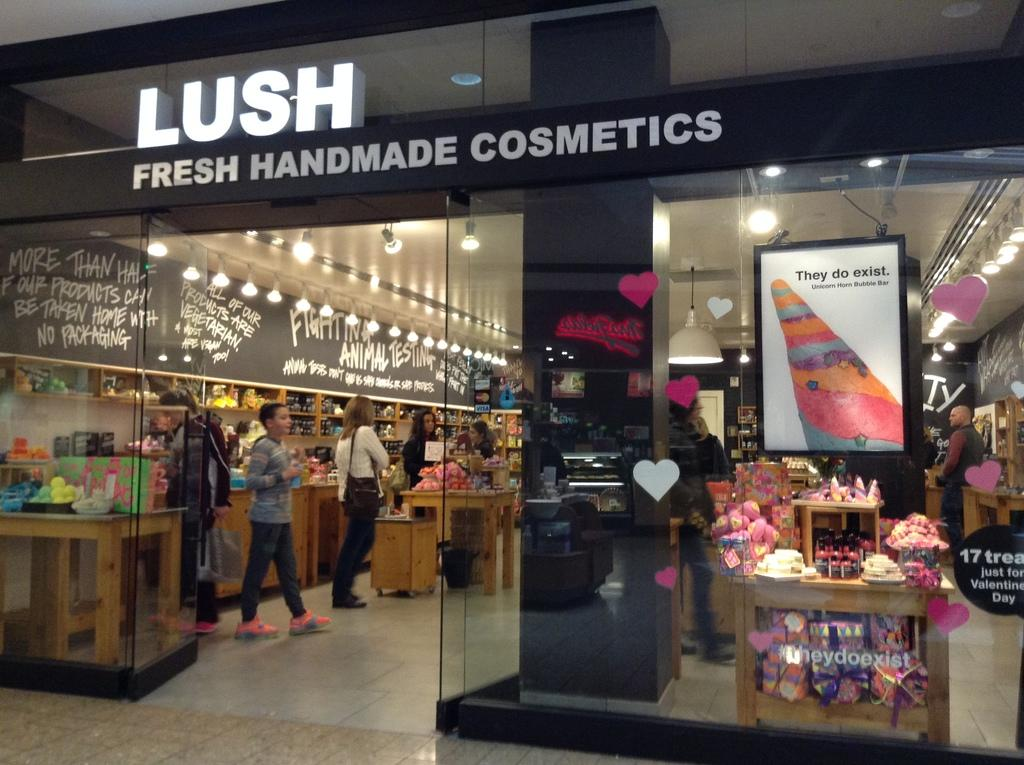<image>
Give a short and clear explanation of the subsequent image. the store front of Lush for fresh handmade cosmetics 